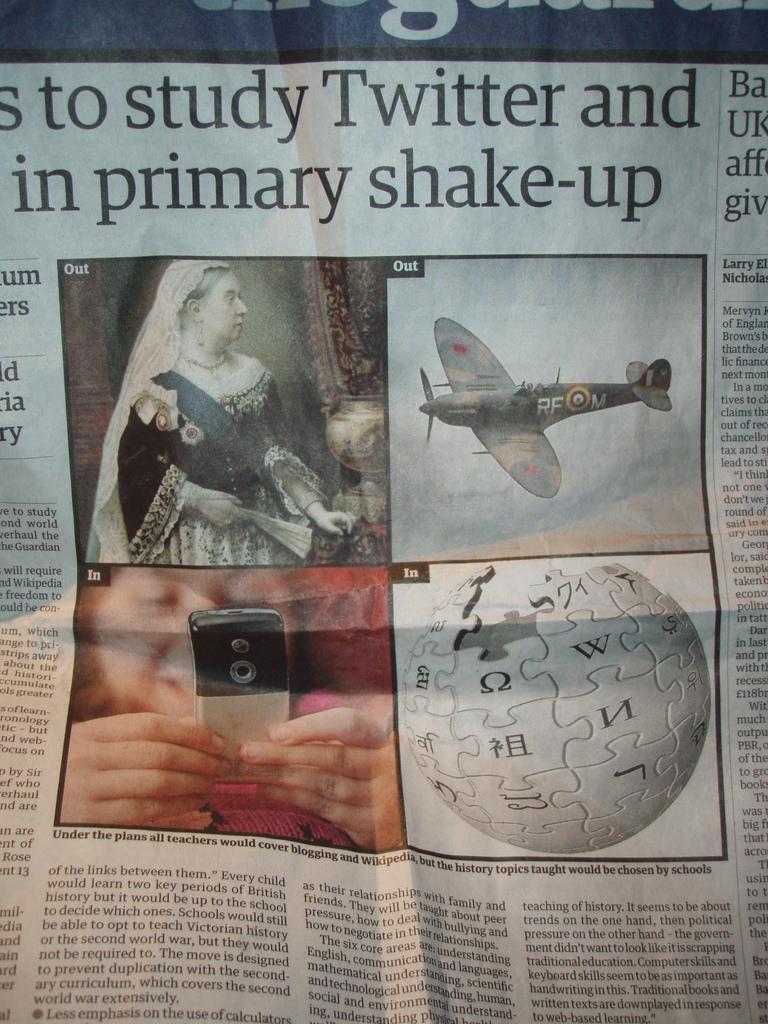Can you describe this image briefly? In this image we can see a newspaper with some images and text. 